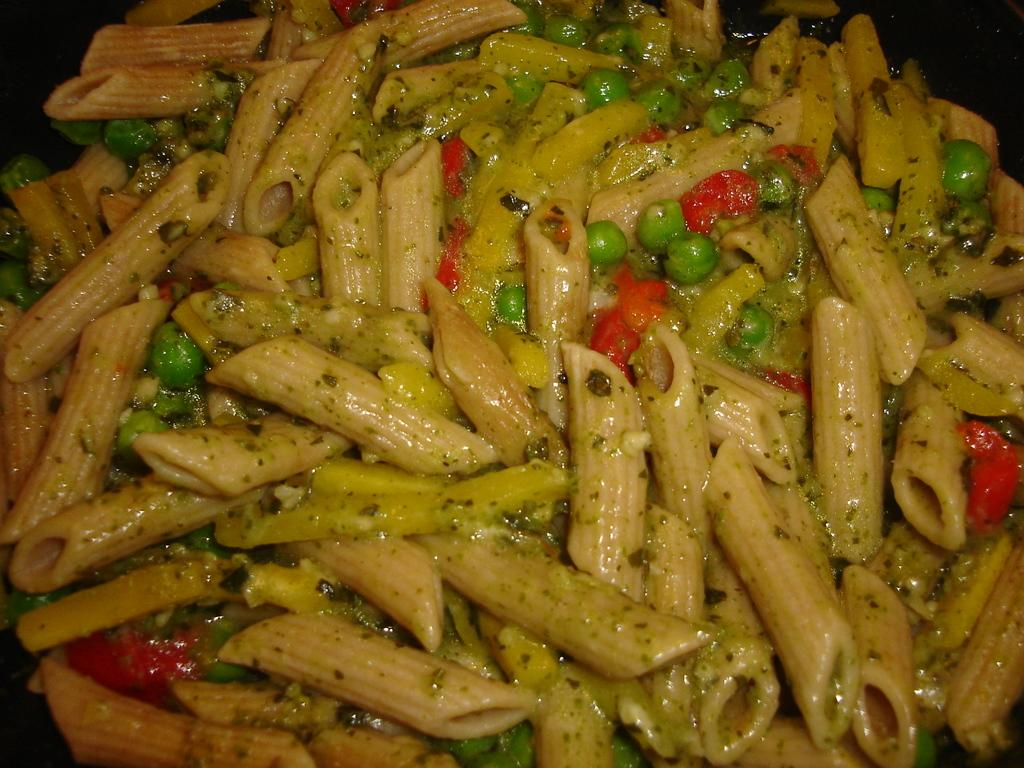What type of food is present in the image? There is pasta in the image. What colors can be seen in the pasta? The pasta is in cream, red, and green colors. What type of argument can be seen between the snail and the pasta in the image? There is no snail or argument present in the image; it only features pasta in cream, red, and green colors. 